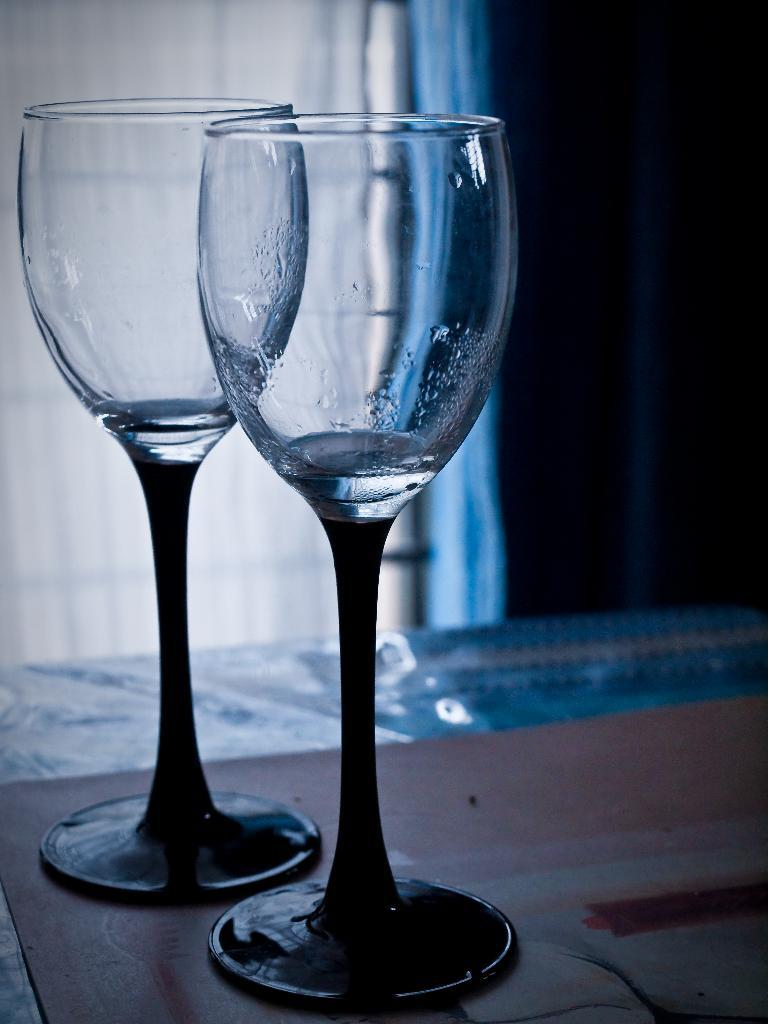How many glasses are visible in the image? There are two glasses in the image. Where are the glasses placed? The glasses are kept on a table. What can be seen in the background of the image? There is a curtain in the background of the image. How many children are sitting on the chair in the image? There is no chair or children present in the image. What type of picture is hanging on the wall in the image? There is no picture or wall present in the image. 